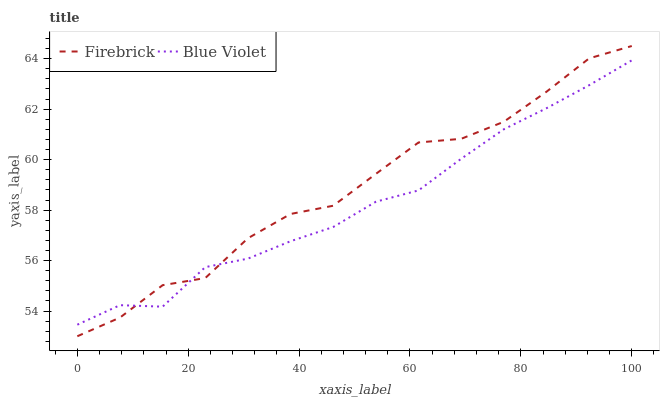Does Blue Violet have the minimum area under the curve?
Answer yes or no. Yes. Does Firebrick have the maximum area under the curve?
Answer yes or no. Yes. Does Blue Violet have the maximum area under the curve?
Answer yes or no. No. Is Blue Violet the smoothest?
Answer yes or no. Yes. Is Firebrick the roughest?
Answer yes or no. Yes. Is Blue Violet the roughest?
Answer yes or no. No. Does Firebrick have the lowest value?
Answer yes or no. Yes. Does Blue Violet have the lowest value?
Answer yes or no. No. Does Firebrick have the highest value?
Answer yes or no. Yes. Does Blue Violet have the highest value?
Answer yes or no. No. Does Blue Violet intersect Firebrick?
Answer yes or no. Yes. Is Blue Violet less than Firebrick?
Answer yes or no. No. Is Blue Violet greater than Firebrick?
Answer yes or no. No. 